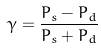<formula> <loc_0><loc_0><loc_500><loc_500>\gamma = \frac { P _ { s } - P _ { d } } { P _ { s } + P _ { d } }</formula> 